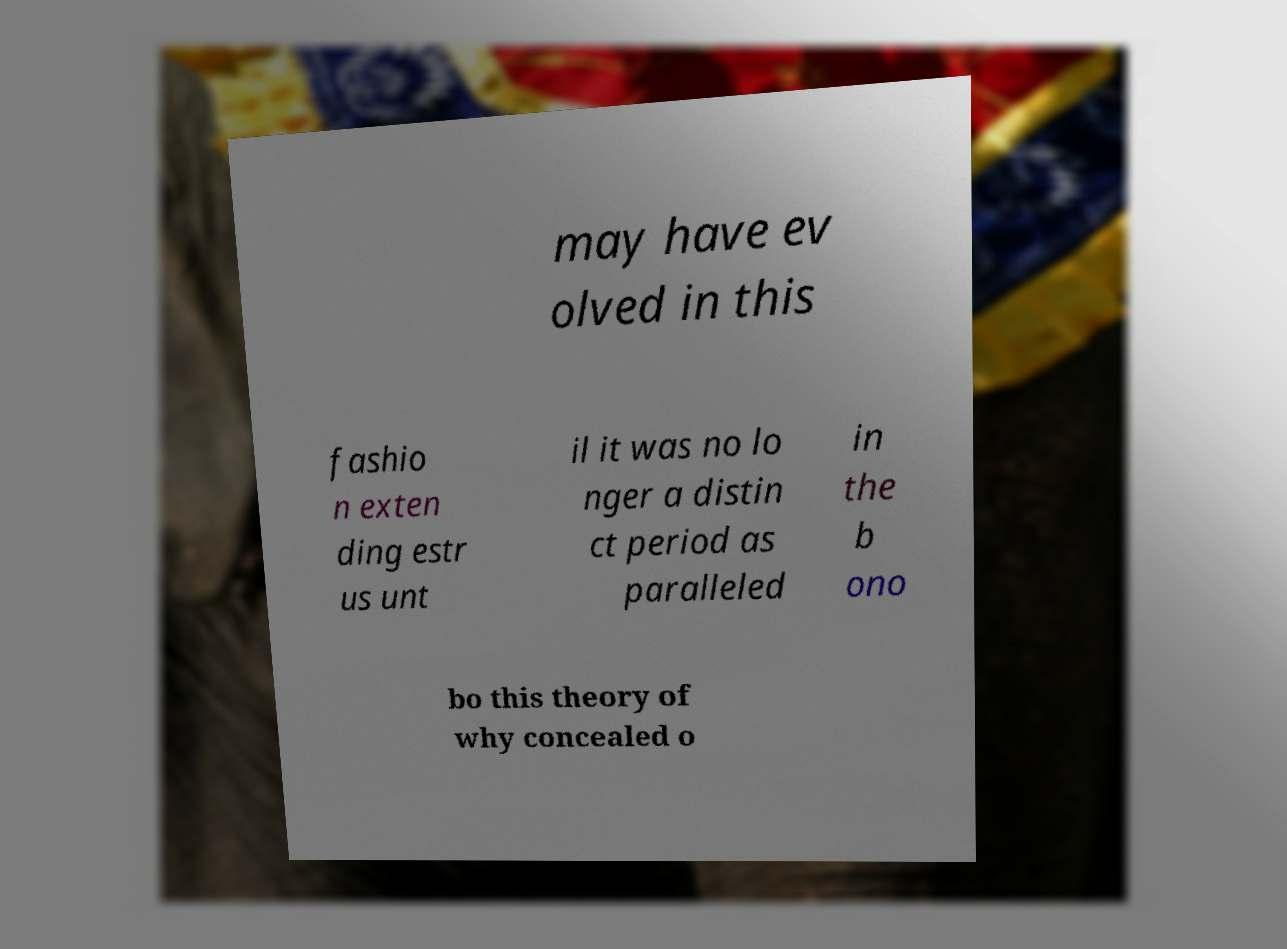Please read and relay the text visible in this image. What does it say? may have ev olved in this fashio n exten ding estr us unt il it was no lo nger a distin ct period as paralleled in the b ono bo this theory of why concealed o 